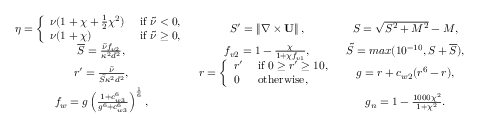<formula> <loc_0><loc_0><loc_500><loc_500>\begin{array} { c c c } { \eta = \left \{ \begin{array} { l l } { \nu ( 1 + \chi + \frac { 1 } { 2 } \chi ^ { 2 } ) } & { i f \tilde { \nu } < 0 , } \\ { \nu ( 1 + \chi ) } & { i f \tilde { \nu } \geq 0 , } \end{array} } & { { S } ^ { \prime } = \left \| \nabla \times U \right \| , } & { { S } = \sqrt { { S } ^ { 2 } + M ^ { 2 } } - M , } \\ { \overline { S } = \frac { \tilde { \nu } f _ { v 2 } } { \kappa ^ { 2 } d ^ { 2 } } , } & { f _ { v 2 } = 1 - \frac { \chi } { 1 + \chi f _ { v 1 } } , } & { \tilde { S } = \max ( 1 0 ^ { - 1 0 } , S + \overline { S } ) , } \\ { { r } ^ { \prime } = \frac { \tilde { \nu } } { \tilde { S } \kappa ^ { 2 } d ^ { 2 } } , } & { r = \left \{ \begin{array} { l l } { { r } ^ { \prime } } & { i f 0 \geq { r } ^ { \prime } \geq 1 0 , } \\ { 0 } & { o t h e r w i s e , } \end{array} } & { g = r + c _ { w 2 } ( r ^ { 6 } - r ) , } \\ { f _ { w } = g \left ( \frac { 1 + c _ { w 3 } ^ { 6 } } { g ^ { 6 } + c _ { w 3 } ^ { 6 } } \right ) ^ { \frac { 1 } { 6 } } , } & & { g _ { n } = 1 - \frac { 1 0 0 0 \chi ^ { 2 } } { 1 + \chi ^ { 2 } } . } \end{array}</formula> 